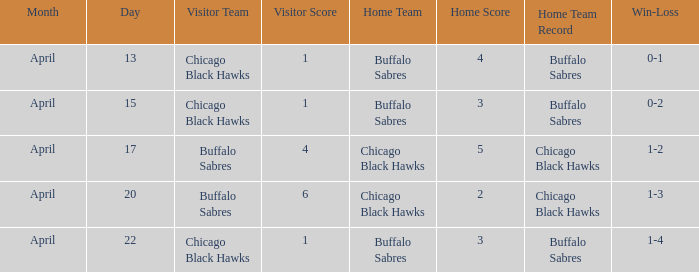Which Score has a Record of 0-1? 1–4. 